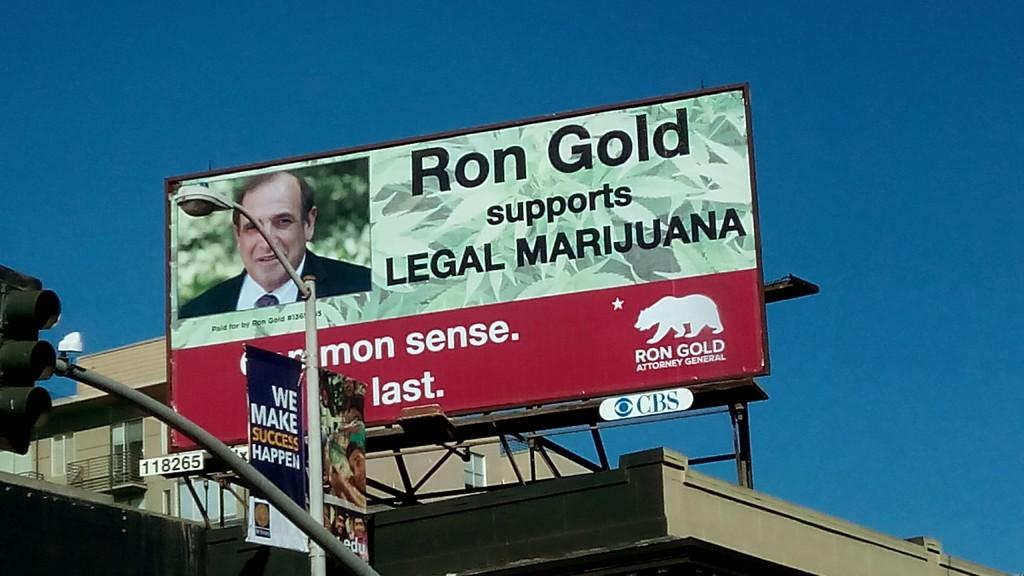<image>
Offer a succinct explanation of the picture presented. Ron Gold has a billboard showing his support of legal marijuana. 